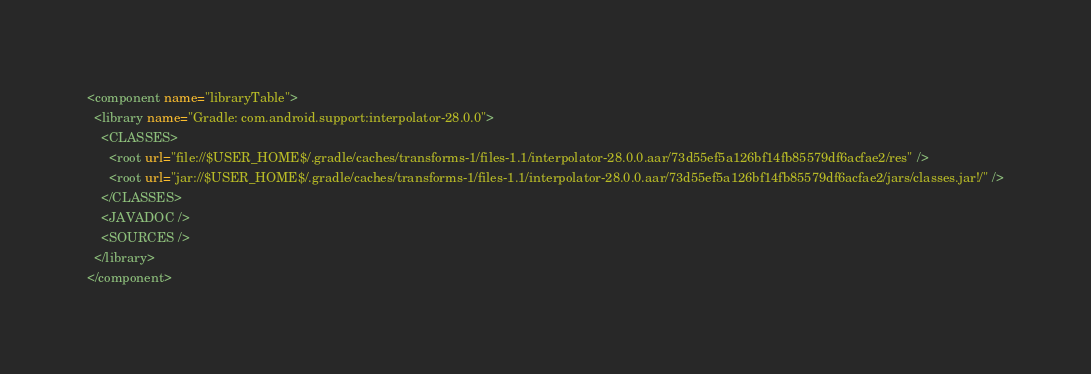Convert code to text. <code><loc_0><loc_0><loc_500><loc_500><_XML_><component name="libraryTable">
  <library name="Gradle: com.android.support:interpolator-28.0.0">
    <CLASSES>
      <root url="file://$USER_HOME$/.gradle/caches/transforms-1/files-1.1/interpolator-28.0.0.aar/73d55ef5a126bf14fb85579df6acfae2/res" />
      <root url="jar://$USER_HOME$/.gradle/caches/transforms-1/files-1.1/interpolator-28.0.0.aar/73d55ef5a126bf14fb85579df6acfae2/jars/classes.jar!/" />
    </CLASSES>
    <JAVADOC />
    <SOURCES />
  </library>
</component></code> 